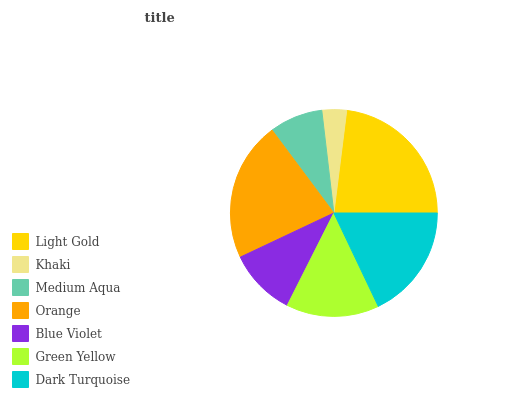Is Khaki the minimum?
Answer yes or no. Yes. Is Light Gold the maximum?
Answer yes or no. Yes. Is Medium Aqua the minimum?
Answer yes or no. No. Is Medium Aqua the maximum?
Answer yes or no. No. Is Medium Aqua greater than Khaki?
Answer yes or no. Yes. Is Khaki less than Medium Aqua?
Answer yes or no. Yes. Is Khaki greater than Medium Aqua?
Answer yes or no. No. Is Medium Aqua less than Khaki?
Answer yes or no. No. Is Green Yellow the high median?
Answer yes or no. Yes. Is Green Yellow the low median?
Answer yes or no. Yes. Is Khaki the high median?
Answer yes or no. No. Is Dark Turquoise the low median?
Answer yes or no. No. 